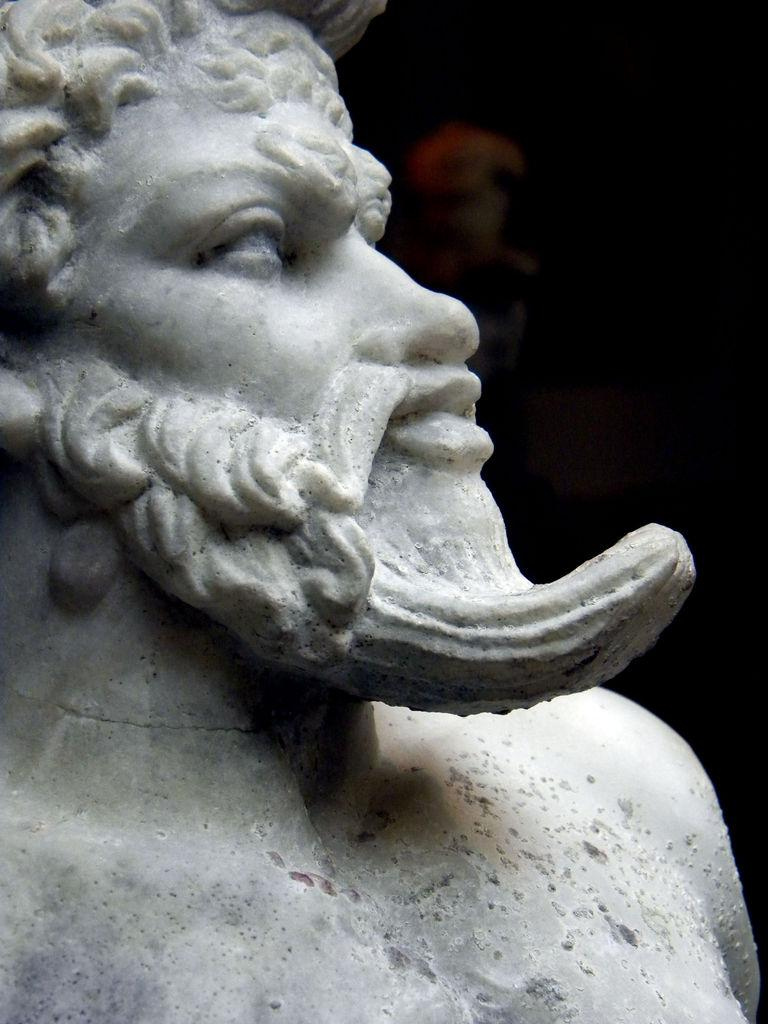What is the main subject of the image? There is a statue in the image. Can you describe the statue? The statue is of a person. What type of marble is used to make the loaf in the image? There is no loaf present in the image, and therefore no marble can be associated with it. 